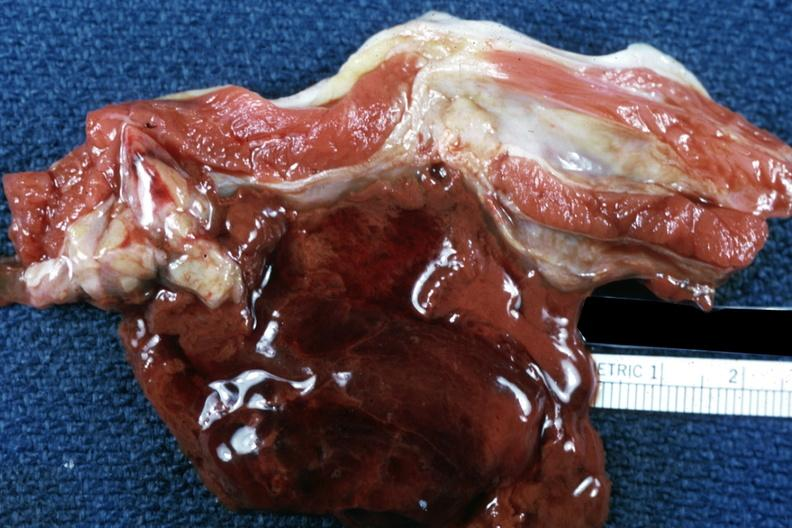what does this image show?
Answer the question using a single word or phrase. Flank muscle hematoma old showing typical chocolate appearance of blood coagulum young female with lupus and thrombocytopenia 